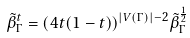<formula> <loc_0><loc_0><loc_500><loc_500>\tilde { \beta } _ { \Gamma } ^ { t } = ( 4 t ( 1 - t ) ) ^ { | V ( \Gamma ) | - 2 } \tilde { \beta } _ { \Gamma } ^ { \frac { 1 } { 2 } }</formula> 